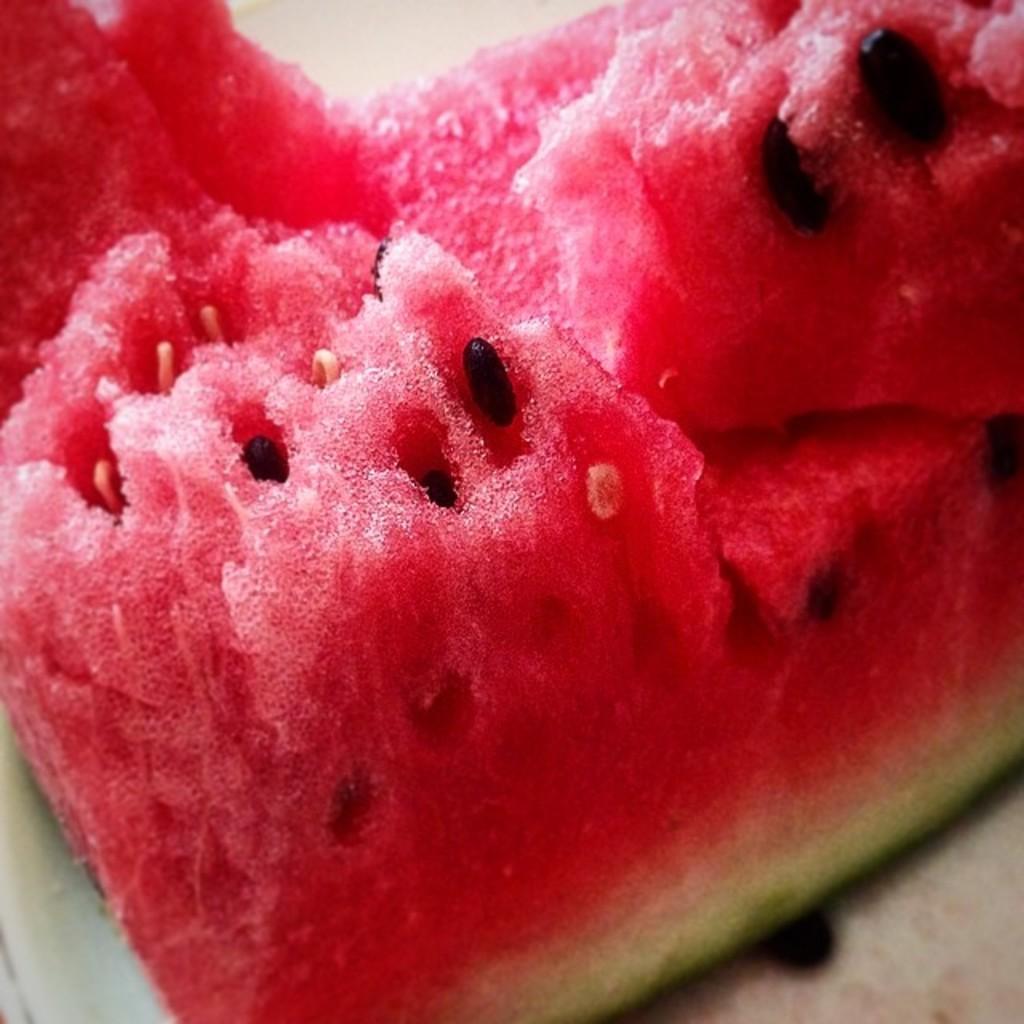How would you summarize this image in a sentence or two? In the center of the image we can see a slice of watermelon and also we can see some seeds. 